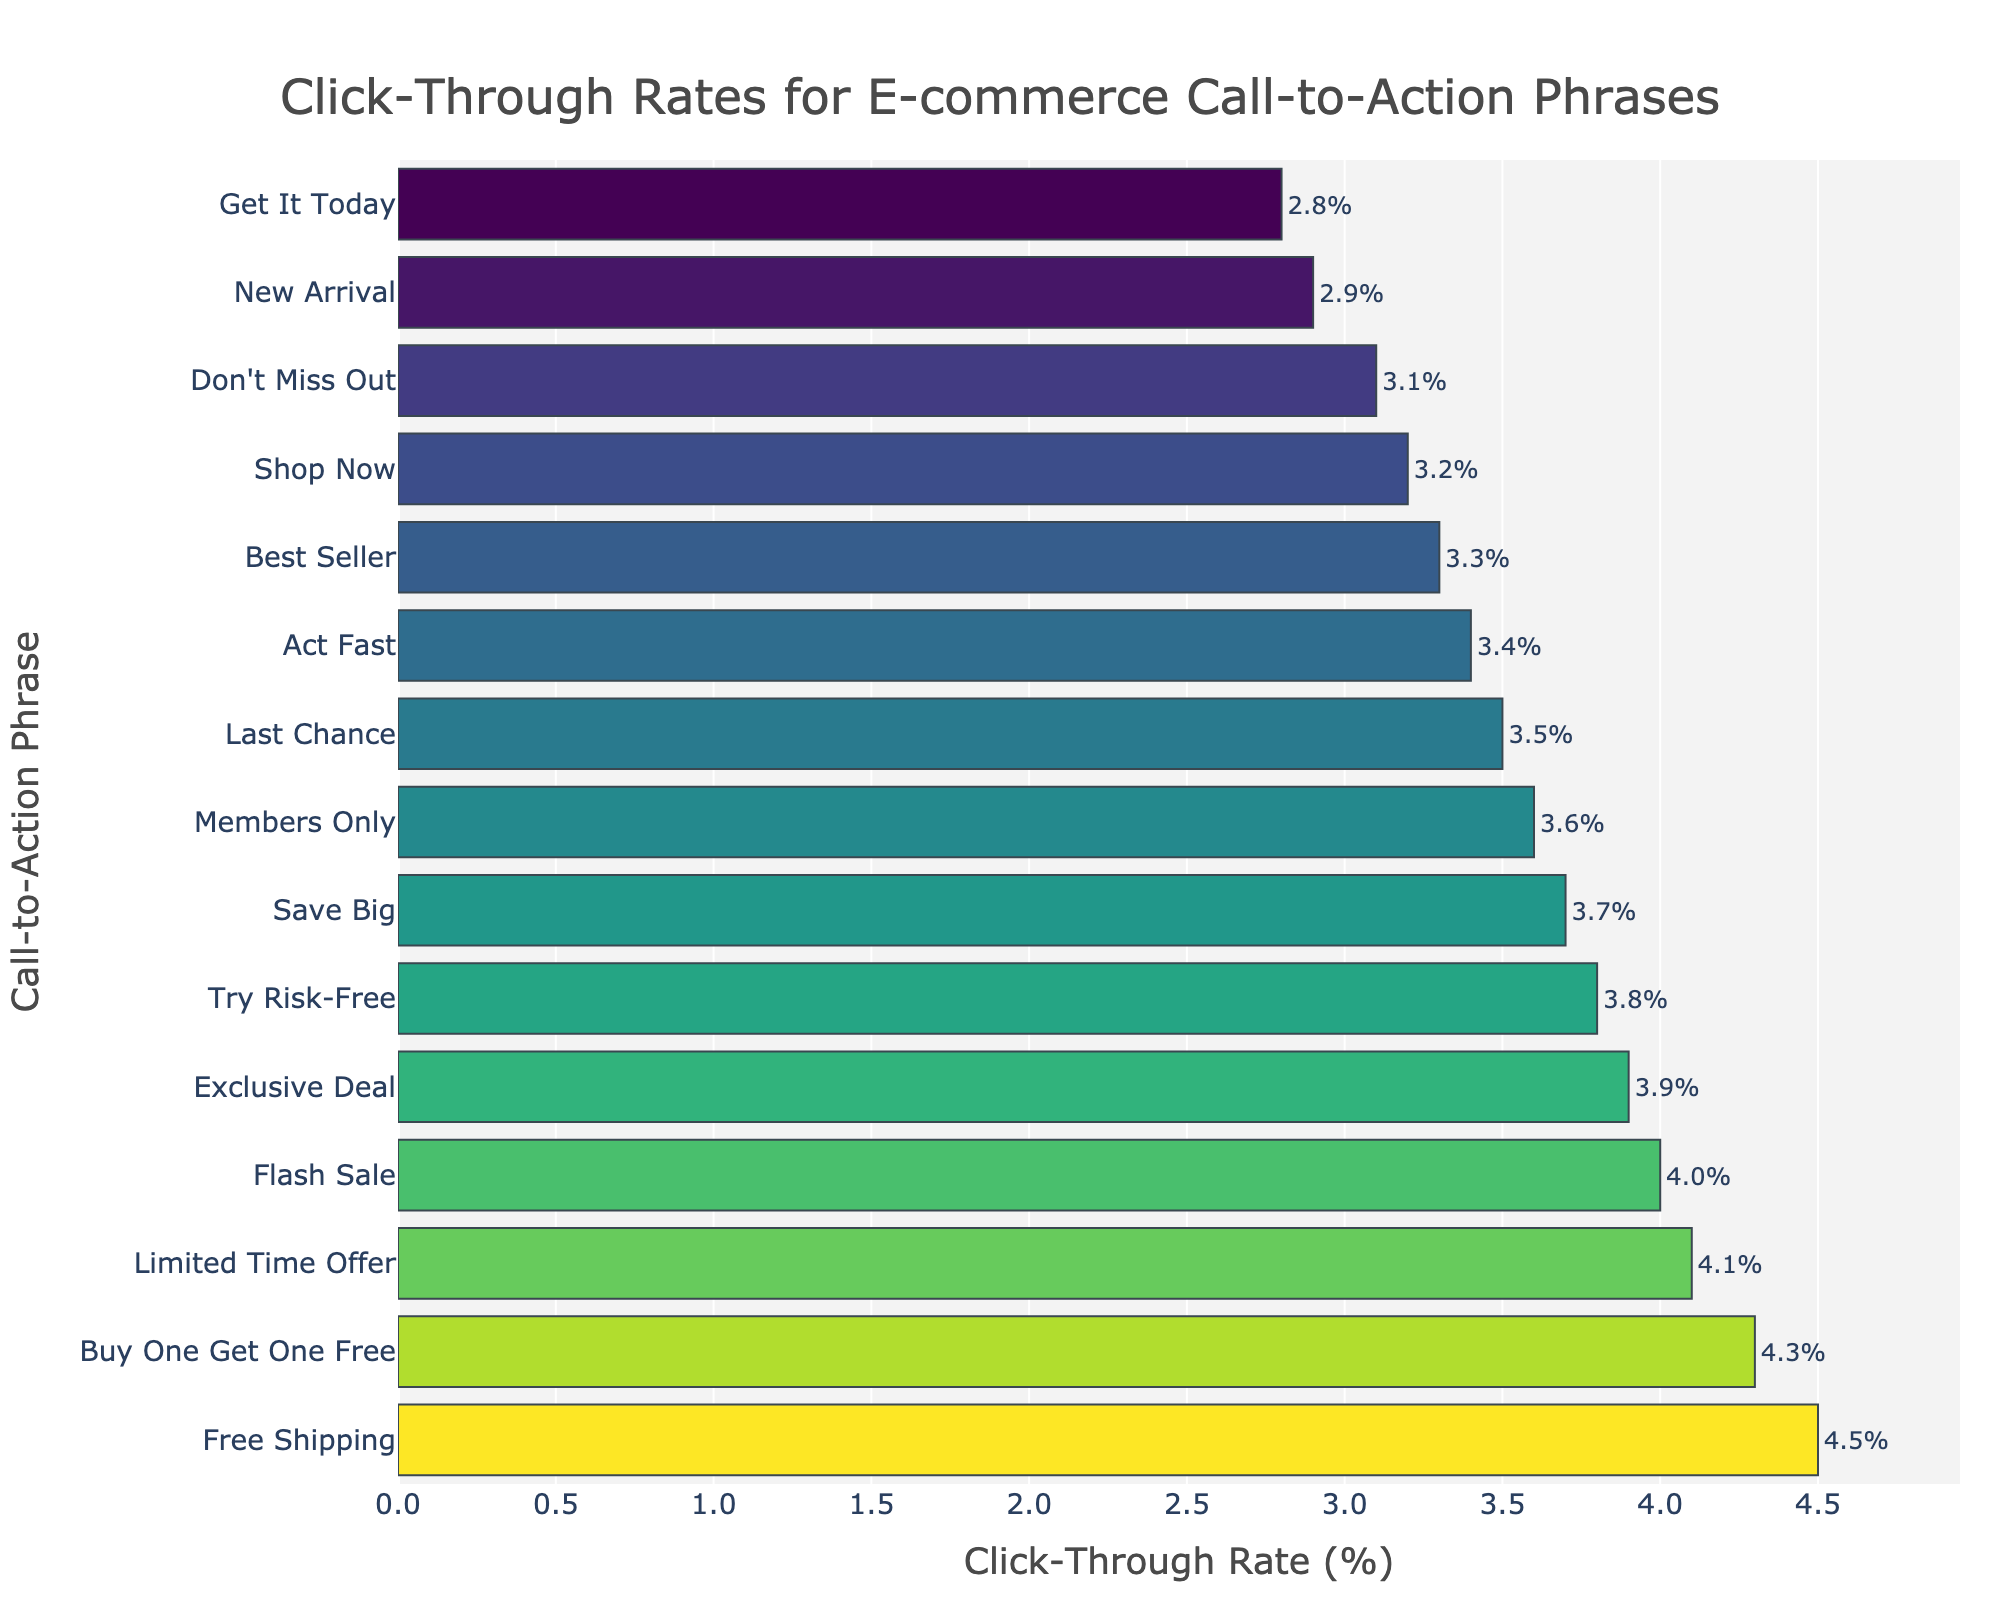Which call-to-action phrase has the highest click-through rate (CTR)? The bar representing "Free Shipping" is the longest and positioned at the top of the sorted list, indicating it has the highest CTR.
Answer: Free Shipping What is the click-through rate for the "Flash Sale" phrase? The bar labeled "Flash Sale" has a click-through rate value displayed at the end. By examining the chart, this value is shown as 4.0%.
Answer: 4.0% Which phrase has a higher CTR: "New Arrival" or "Don't Miss Out"? By comparing the lengths of the bars for "New Arrival" and "Don't Miss Out," we see the bar for "New Arrival" is slightly longer, indicating a higher CTR.
Answer: New Arrival What is the average CTR of the top 3 phrases? The top 3 phrases are "Free Shipping" (4.5%), "Buy One Get One Free" (4.3%), and "Limited Time Offer" (4.1%). The average CTR is (4.5 + 4.3 + 4.1) / 3.
Answer: 4.3% How many phrases have a CTR greater than 3.5%? Count the bars that extend beyond the 3.5% mark on the x-axis. These bars are "Free Shipping", "Buy One Get One Free", "Limited Time Offer", "Flash Sale", "Exclusive Deal", "Try Risk-Free", and "Save Big", resulting in 7 phrases.
Answer: 7 Which phrases have a CTR less than "Shop Now"? "Shop Now" has a CTR of 3.2%. Phrases with shorter bars than "Shop Now" are "New Arrival" (2.9%), "Get It Today" (2.8%), and "Don't Miss Out" (3.1%).
Answer: New Arrival, Get It Today, Don't Miss Out What is the difference in CTR between "Act Fast" and "Members Only"? "Act Fast" has a CTR of 3.4%, and "Members Only" has a CTR of 3.6%. The difference is 3.6% - 3.4% = 0.2%.
Answer: 0.2% Which phrase has the closest CTR to the median? The median value for 15 sorted phrases is the 8th value. The 8th value sorted in descending order is "Act Fast" (3.4%), the closest phrase to the median in the plot.
Answer: Act Fast 